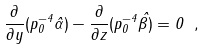Convert formula to latex. <formula><loc_0><loc_0><loc_500><loc_500>\frac { \partial } { \partial y } ( p _ { 0 } ^ { - 4 } \hat { \alpha } ) - \frac { \partial } { \partial z } ( p _ { 0 } ^ { - 4 } \hat { \beta ) } = 0 \ ,</formula> 